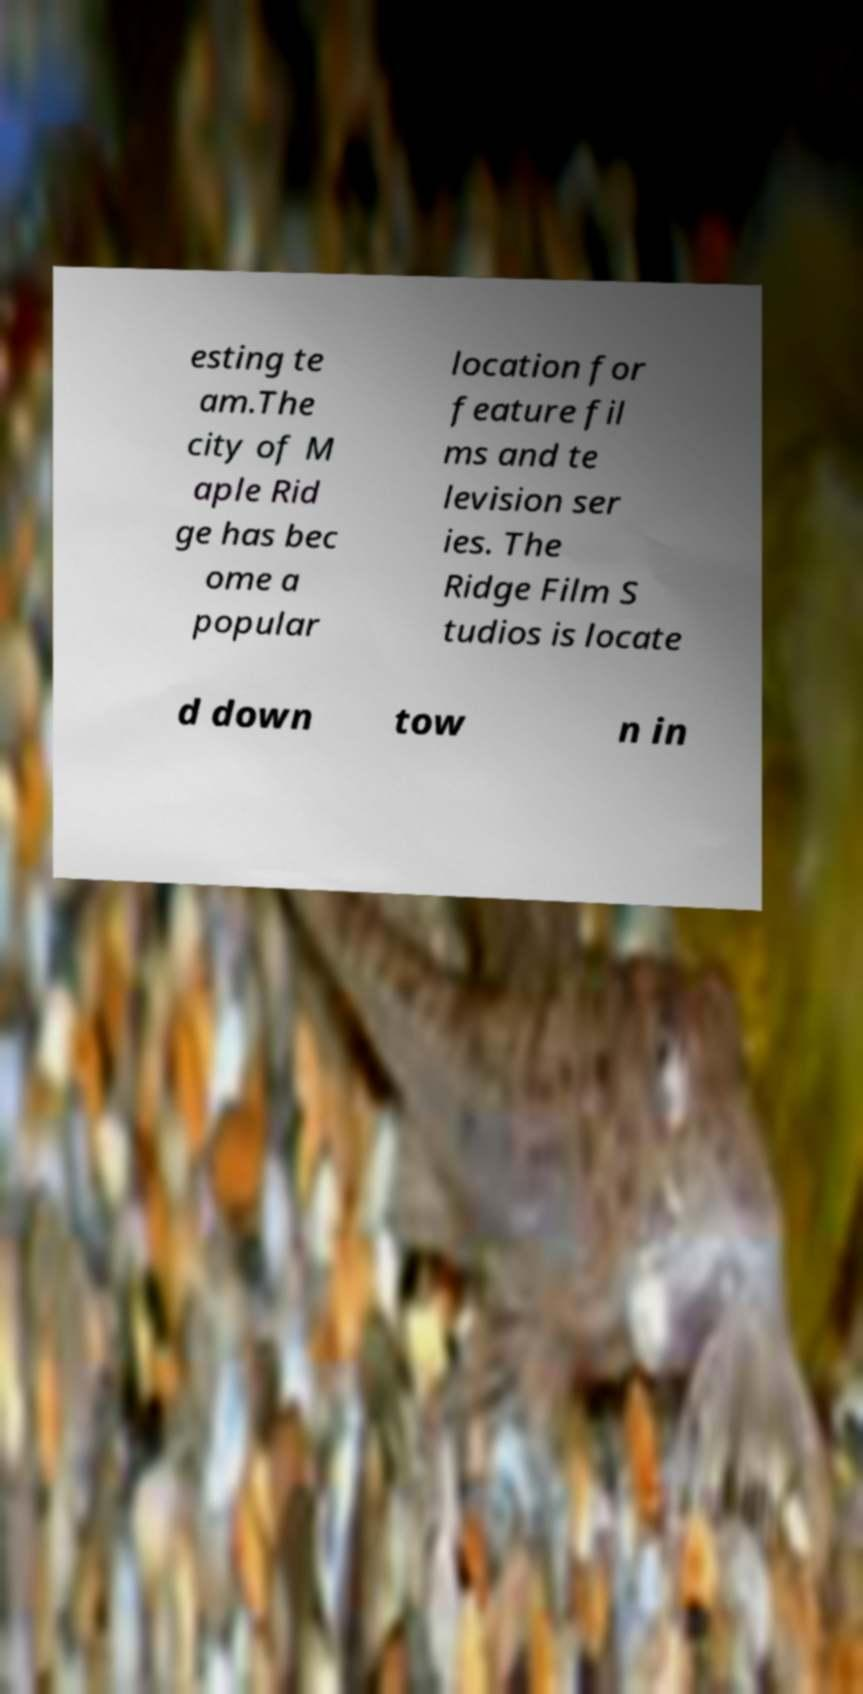What messages or text are displayed in this image? I need them in a readable, typed format. esting te am.The city of M aple Rid ge has bec ome a popular location for feature fil ms and te levision ser ies. The Ridge Film S tudios is locate d down tow n in 